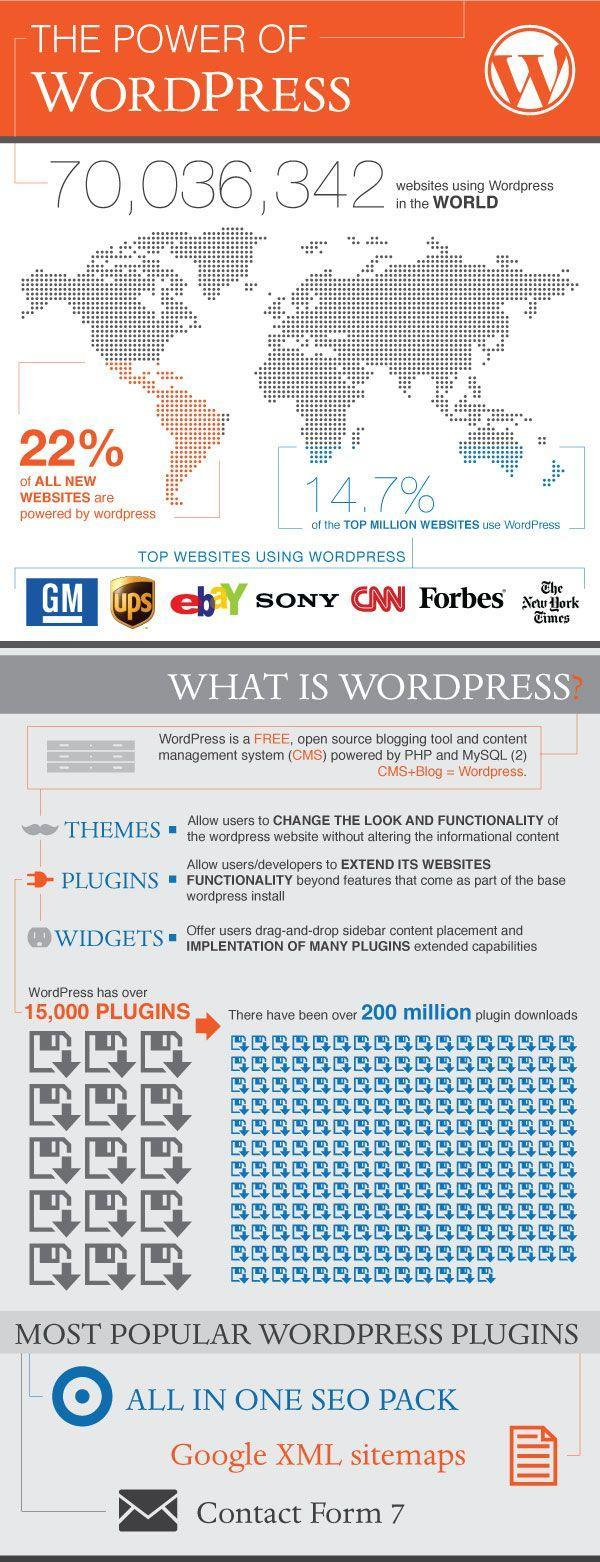How many websites using WordPress mentioned in this infographic?
Answer the question with a short phrase. 7 What percentage of all new websites are not powered by WordPress? 78% 